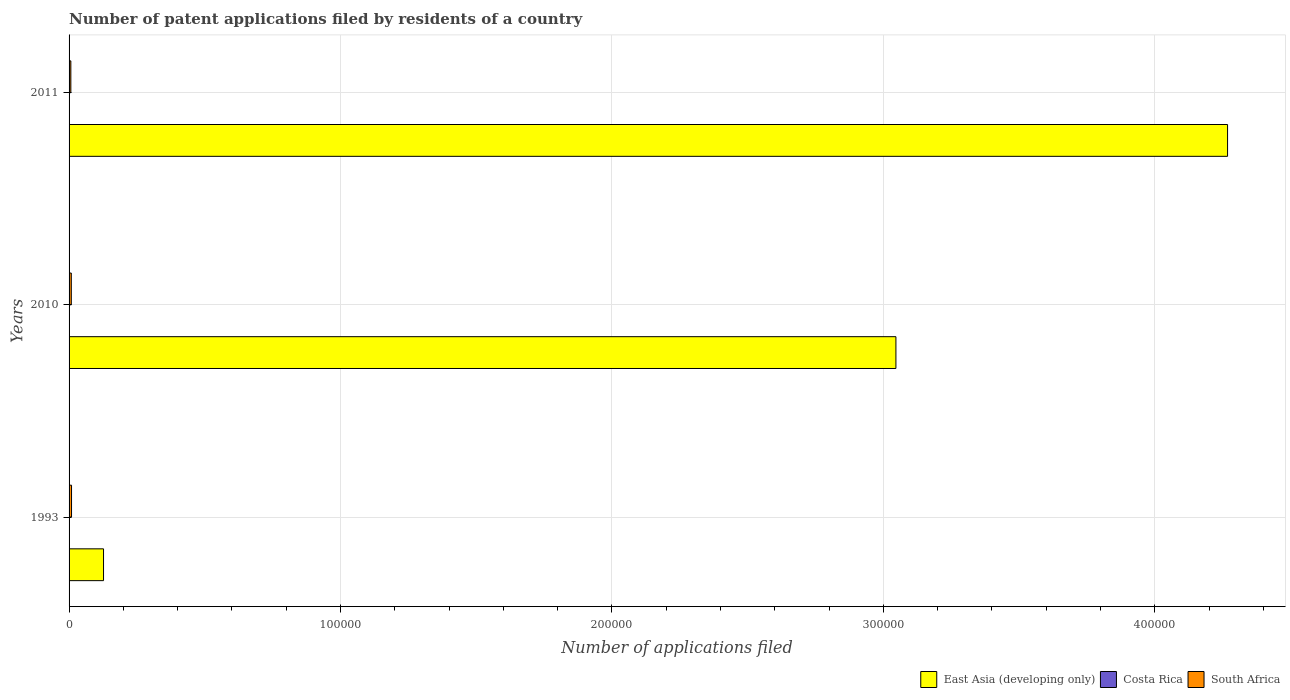Are the number of bars per tick equal to the number of legend labels?
Ensure brevity in your answer.  Yes. Are the number of bars on each tick of the Y-axis equal?
Your answer should be compact. Yes. How many bars are there on the 3rd tick from the top?
Your answer should be very brief. 3. How many bars are there on the 1st tick from the bottom?
Make the answer very short. 3. What is the label of the 3rd group of bars from the top?
Offer a very short reply. 1993. In how many cases, is the number of bars for a given year not equal to the number of legend labels?
Provide a short and direct response. 0. What is the number of applications filed in South Africa in 1993?
Your response must be concise. 904. Across all years, what is the maximum number of applications filed in South Africa?
Provide a short and direct response. 904. Across all years, what is the minimum number of applications filed in South Africa?
Make the answer very short. 656. In which year was the number of applications filed in South Africa minimum?
Your answer should be compact. 2011. What is the total number of applications filed in South Africa in the graph?
Offer a terse response. 2381. What is the difference between the number of applications filed in East Asia (developing only) in 2010 and that in 2011?
Your response must be concise. -1.22e+05. What is the difference between the number of applications filed in Costa Rica in 2010 and the number of applications filed in East Asia (developing only) in 2011?
Your answer should be compact. -4.27e+05. What is the average number of applications filed in East Asia (developing only) per year?
Offer a terse response. 2.48e+05. In the year 2010, what is the difference between the number of applications filed in South Africa and number of applications filed in East Asia (developing only)?
Offer a very short reply. -3.04e+05. What is the ratio of the number of applications filed in East Asia (developing only) in 1993 to that in 2010?
Offer a very short reply. 0.04. What is the difference between the highest and the second highest number of applications filed in East Asia (developing only)?
Provide a succinct answer. 1.22e+05. What is the difference between the highest and the lowest number of applications filed in East Asia (developing only)?
Make the answer very short. 4.14e+05. What does the 1st bar from the top in 2010 represents?
Provide a short and direct response. South Africa. What does the 1st bar from the bottom in 2011 represents?
Give a very brief answer. East Asia (developing only). How many bars are there?
Your response must be concise. 9. Are all the bars in the graph horizontal?
Your answer should be very brief. Yes. What is the title of the graph?
Give a very brief answer. Number of patent applications filed by residents of a country. Does "French Polynesia" appear as one of the legend labels in the graph?
Offer a very short reply. No. What is the label or title of the X-axis?
Your answer should be compact. Number of applications filed. What is the Number of applications filed of East Asia (developing only) in 1993?
Give a very brief answer. 1.27e+04. What is the Number of applications filed of South Africa in 1993?
Your answer should be compact. 904. What is the Number of applications filed in East Asia (developing only) in 2010?
Your answer should be compact. 3.05e+05. What is the Number of applications filed of South Africa in 2010?
Make the answer very short. 821. What is the Number of applications filed in East Asia (developing only) in 2011?
Provide a succinct answer. 4.27e+05. What is the Number of applications filed of Costa Rica in 2011?
Provide a short and direct response. 14. What is the Number of applications filed in South Africa in 2011?
Provide a succinct answer. 656. Across all years, what is the maximum Number of applications filed of East Asia (developing only)?
Your answer should be compact. 4.27e+05. Across all years, what is the maximum Number of applications filed in Costa Rica?
Your answer should be compact. 29. Across all years, what is the maximum Number of applications filed in South Africa?
Your answer should be very brief. 904. Across all years, what is the minimum Number of applications filed of East Asia (developing only)?
Provide a short and direct response. 1.27e+04. Across all years, what is the minimum Number of applications filed in Costa Rica?
Your response must be concise. 8. Across all years, what is the minimum Number of applications filed of South Africa?
Your response must be concise. 656. What is the total Number of applications filed of East Asia (developing only) in the graph?
Make the answer very short. 7.44e+05. What is the total Number of applications filed of South Africa in the graph?
Ensure brevity in your answer.  2381. What is the difference between the Number of applications filed of East Asia (developing only) in 1993 and that in 2010?
Ensure brevity in your answer.  -2.92e+05. What is the difference between the Number of applications filed in East Asia (developing only) in 1993 and that in 2011?
Keep it short and to the point. -4.14e+05. What is the difference between the Number of applications filed in South Africa in 1993 and that in 2011?
Provide a short and direct response. 248. What is the difference between the Number of applications filed in East Asia (developing only) in 2010 and that in 2011?
Provide a succinct answer. -1.22e+05. What is the difference between the Number of applications filed in South Africa in 2010 and that in 2011?
Ensure brevity in your answer.  165. What is the difference between the Number of applications filed in East Asia (developing only) in 1993 and the Number of applications filed in Costa Rica in 2010?
Your response must be concise. 1.27e+04. What is the difference between the Number of applications filed in East Asia (developing only) in 1993 and the Number of applications filed in South Africa in 2010?
Make the answer very short. 1.19e+04. What is the difference between the Number of applications filed in Costa Rica in 1993 and the Number of applications filed in South Africa in 2010?
Provide a short and direct response. -792. What is the difference between the Number of applications filed of East Asia (developing only) in 1993 and the Number of applications filed of Costa Rica in 2011?
Give a very brief answer. 1.27e+04. What is the difference between the Number of applications filed in East Asia (developing only) in 1993 and the Number of applications filed in South Africa in 2011?
Offer a terse response. 1.20e+04. What is the difference between the Number of applications filed of Costa Rica in 1993 and the Number of applications filed of South Africa in 2011?
Offer a terse response. -627. What is the difference between the Number of applications filed of East Asia (developing only) in 2010 and the Number of applications filed of Costa Rica in 2011?
Your answer should be very brief. 3.05e+05. What is the difference between the Number of applications filed of East Asia (developing only) in 2010 and the Number of applications filed of South Africa in 2011?
Provide a short and direct response. 3.04e+05. What is the difference between the Number of applications filed of Costa Rica in 2010 and the Number of applications filed of South Africa in 2011?
Offer a very short reply. -648. What is the average Number of applications filed in East Asia (developing only) per year?
Offer a very short reply. 2.48e+05. What is the average Number of applications filed of South Africa per year?
Give a very brief answer. 793.67. In the year 1993, what is the difference between the Number of applications filed of East Asia (developing only) and Number of applications filed of Costa Rica?
Your answer should be very brief. 1.27e+04. In the year 1993, what is the difference between the Number of applications filed of East Asia (developing only) and Number of applications filed of South Africa?
Keep it short and to the point. 1.18e+04. In the year 1993, what is the difference between the Number of applications filed in Costa Rica and Number of applications filed in South Africa?
Give a very brief answer. -875. In the year 2010, what is the difference between the Number of applications filed in East Asia (developing only) and Number of applications filed in Costa Rica?
Give a very brief answer. 3.05e+05. In the year 2010, what is the difference between the Number of applications filed in East Asia (developing only) and Number of applications filed in South Africa?
Your answer should be compact. 3.04e+05. In the year 2010, what is the difference between the Number of applications filed in Costa Rica and Number of applications filed in South Africa?
Your answer should be compact. -813. In the year 2011, what is the difference between the Number of applications filed of East Asia (developing only) and Number of applications filed of Costa Rica?
Offer a very short reply. 4.27e+05. In the year 2011, what is the difference between the Number of applications filed in East Asia (developing only) and Number of applications filed in South Africa?
Offer a very short reply. 4.26e+05. In the year 2011, what is the difference between the Number of applications filed in Costa Rica and Number of applications filed in South Africa?
Your response must be concise. -642. What is the ratio of the Number of applications filed in East Asia (developing only) in 1993 to that in 2010?
Provide a succinct answer. 0.04. What is the ratio of the Number of applications filed of Costa Rica in 1993 to that in 2010?
Your answer should be very brief. 3.62. What is the ratio of the Number of applications filed in South Africa in 1993 to that in 2010?
Ensure brevity in your answer.  1.1. What is the ratio of the Number of applications filed of East Asia (developing only) in 1993 to that in 2011?
Your response must be concise. 0.03. What is the ratio of the Number of applications filed of Costa Rica in 1993 to that in 2011?
Keep it short and to the point. 2.07. What is the ratio of the Number of applications filed in South Africa in 1993 to that in 2011?
Offer a terse response. 1.38. What is the ratio of the Number of applications filed of East Asia (developing only) in 2010 to that in 2011?
Provide a short and direct response. 0.71. What is the ratio of the Number of applications filed of South Africa in 2010 to that in 2011?
Your answer should be very brief. 1.25. What is the difference between the highest and the second highest Number of applications filed of East Asia (developing only)?
Offer a very short reply. 1.22e+05. What is the difference between the highest and the second highest Number of applications filed in Costa Rica?
Offer a terse response. 15. What is the difference between the highest and the lowest Number of applications filed of East Asia (developing only)?
Provide a short and direct response. 4.14e+05. What is the difference between the highest and the lowest Number of applications filed of Costa Rica?
Provide a succinct answer. 21. What is the difference between the highest and the lowest Number of applications filed in South Africa?
Offer a very short reply. 248. 